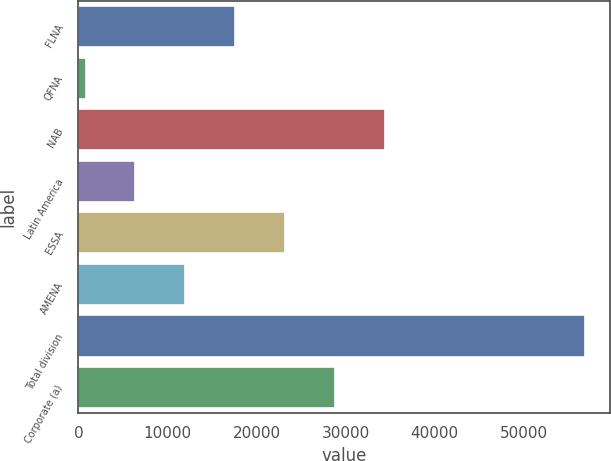Convert chart to OTSL. <chart><loc_0><loc_0><loc_500><loc_500><bar_chart><fcel>FLNA<fcel>QFNA<fcel>NAB<fcel>Latin America<fcel>ESSA<fcel>AMENA<fcel>Total division<fcel>Corporate (a)<nl><fcel>17621.2<fcel>811<fcel>34431.4<fcel>6414.4<fcel>23224.6<fcel>12017.8<fcel>56845<fcel>28828<nl></chart> 